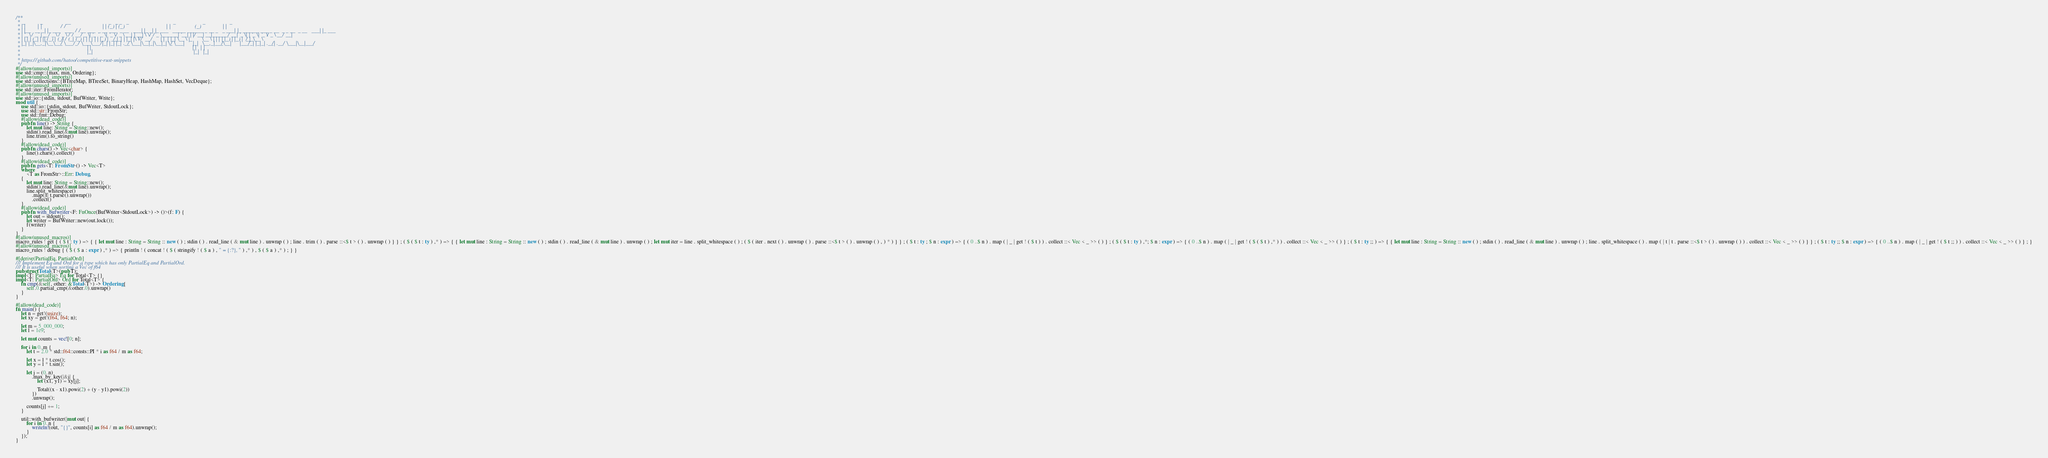<code> <loc_0><loc_0><loc_500><loc_500><_Rust_>/**
 *  _           _                 __                            _   _ _   _                                 _                    _                  _
 * | |         | |               / /                           | | (_) | (_)                               | |                  (_)                | |
 * | |__   __ _| |_ ___   ___   / /__ ___  _ __ ___  _ __   ___| |_ _| |_ ___   _____ ______ _ __ _   _ ___| |_ ______ ___ _ __  _ _ __  _ __   ___| |_ ___
 * | '_ \ / _` | __/ _ \ / _ \ / / __/ _ \| '_ ` _ \| '_ \ / _ \ __| | __| \ \ / / _ \______| '__| | | / __| __|______/ __| '_ \| | '_ \| '_ \ / _ \ __/ __|
 * | | | | (_| | || (_) | (_) / / (_| (_) | | | | | | |_) |  __/ |_| | |_| |\ V /  __/      | |  | |_| \__ \ |_       \__ \ | | | | |_) | |_) |  __/ |_\__ \
 * |_| |_|\__,_|\__\___/ \___/_/ \___\___/|_| |_| |_| .__/ \___|\__|_|\__|_| \_/ \___|      |_|   \__,_|___/\__|      |___/_| |_|_| .__/| .__/ \___|\__|___/
 *                                                  | |                                                                           | |   | |
 *                                                  |_|                                                                           |_|   |_|
 *
 * https://github.com/hatoo/competitive-rust-snippets
 */
#[allow(unused_imports)]
use std::cmp::{max, min, Ordering};
#[allow(unused_imports)]
use std::collections::{BTreeMap, BTreeSet, BinaryHeap, HashMap, HashSet, VecDeque};
#[allow(unused_imports)]
use std::iter::FromIterator;
#[allow(unused_imports)]
use std::io::{stdin, stdout, BufWriter, Write};
mod util {
    use std::io::{stdin, stdout, BufWriter, StdoutLock};
    use std::str::FromStr;
    use std::fmt::Debug;
    #[allow(dead_code)]
    pub fn line() -> String {
        let mut line: String = String::new();
        stdin().read_line(&mut line).unwrap();
        line.trim().to_string()
    }
    #[allow(dead_code)]
    pub fn chars() -> Vec<char> {
        line().chars().collect()
    }
    #[allow(dead_code)]
    pub fn gets<T: FromStr>() -> Vec<T>
    where
        <T as FromStr>::Err: Debug,
    {
        let mut line: String = String::new();
        stdin().read_line(&mut line).unwrap();
        line.split_whitespace()
            .map(|t| t.parse().unwrap())
            .collect()
    }
    #[allow(dead_code)]
    pub fn with_bufwriter<F: FnOnce(BufWriter<StdoutLock>) -> ()>(f: F) {
        let out = stdout();
        let writer = BufWriter::new(out.lock());
        f(writer)
    }
}
#[allow(unused_macros)]
macro_rules ! get { ( $ t : ty ) => { { let mut line : String = String :: new ( ) ; stdin ( ) . read_line ( & mut line ) . unwrap ( ) ; line . trim ( ) . parse ::<$ t > ( ) . unwrap ( ) } } ; ( $ ( $ t : ty ) ,* ) => { { let mut line : String = String :: new ( ) ; stdin ( ) . read_line ( & mut line ) . unwrap ( ) ; let mut iter = line . split_whitespace ( ) ; ( $ ( iter . next ( ) . unwrap ( ) . parse ::<$ t > ( ) . unwrap ( ) , ) * ) } } ; ( $ t : ty ; $ n : expr ) => { ( 0 ..$ n ) . map ( | _ | get ! ( $ t ) ) . collect ::< Vec < _ >> ( ) } ; ( $ ( $ t : ty ) ,*; $ n : expr ) => { ( 0 ..$ n ) . map ( | _ | get ! ( $ ( $ t ) ,* ) ) . collect ::< Vec < _ >> ( ) } ; ( $ t : ty ;; ) => { { let mut line : String = String :: new ( ) ; stdin ( ) . read_line ( & mut line ) . unwrap ( ) ; line . split_whitespace ( ) . map ( | t | t . parse ::<$ t > ( ) . unwrap ( ) ) . collect ::< Vec < _ >> ( ) } } ; ( $ t : ty ;; $ n : expr ) => { ( 0 ..$ n ) . map ( | _ | get ! ( $ t ;; ) ) . collect ::< Vec < _ >> ( ) } ; }
#[allow(unused_macros)]
macro_rules ! debug { ( $ ( $ a : expr ) ,* ) => { println ! ( concat ! ( $ ( stringify ! ( $ a ) , " = {:?}, " ) ,* ) , $ ( $ a ) ,* ) ; } }

#[derive(PartialEq, PartialOrd)]
/// Implement Eq and Ord for a type which has only PartialEq and PartialOrd.
/// It is useful when sorting a Vec of f64
pub struct Total<T>(pub T);
impl<T: PartialEq> Eq for Total<T> {}
impl<T: PartialOrd> Ord for Total<T> {
    fn cmp(&self, other: &Total<T>) -> Ordering {
        self.0.partial_cmp(&other.0).unwrap()
    }
}

#[allow(dead_code)]
fn main() {
    let n = get!(usize);
    let xy = get!(f64, f64; n);

    let m = 5_000_000;
    let l = 1e9;

    let mut counts = vec![0; n];

    for i in 0..m {
        let t = 2.0 * std::f64::consts::PI * i as f64 / m as f64;

        let x = l * t.cos();
        let y = l * t.sin();

        let j = (0..n)
            .max_by_key(|&j| {
                let (x1, y1) = xy[j];

                Total((x - x1).powi(2) + (y - y1).powi(2))
            })
            .unwrap();

        counts[j] += 1;
    }

    util::with_bufwriter(|mut out| {
        for i in 0..n {
            writeln!(out, "{}", counts[i] as f64 / m as f64).unwrap();
        }
    });
}
</code> 